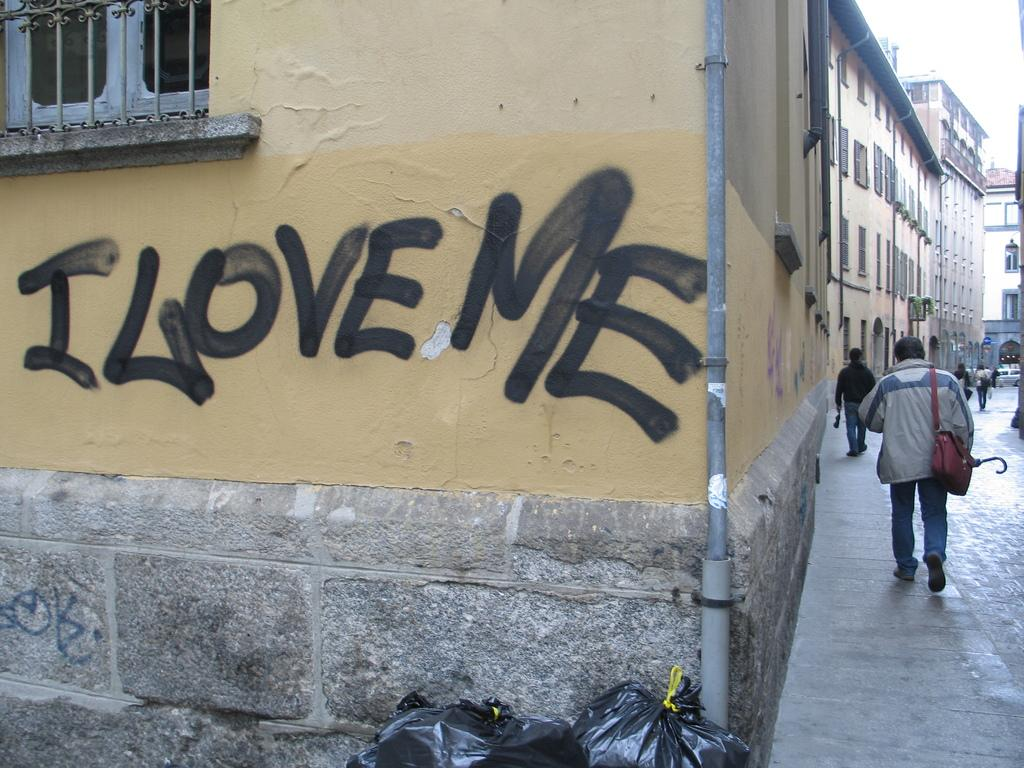What is one of the main features in the image? There is a wall in the image. What else can be seen in the image besides the wall? There are many buildings and a road to the right in the image. What are the people in the image doing? People are walking on the road in the image. What is located at the bottom of the image? There are garbage bags at the bottom of the image. Reasoning: Let's think step by following the guidelines to produce the conversation. We start by identifying the main features in the image, which are the wall and the buildings. Then, we expand the conversation to include the road, people walking, and the garbage bags. Each question is designed to elicit a specific detail about the image that is known from the provided facts. Absurd Question/Answer: What committee is responsible for the achievements of the person in the image? There is no person or achievements mentioned in the image, so it is not possible to determine the committee responsible. 